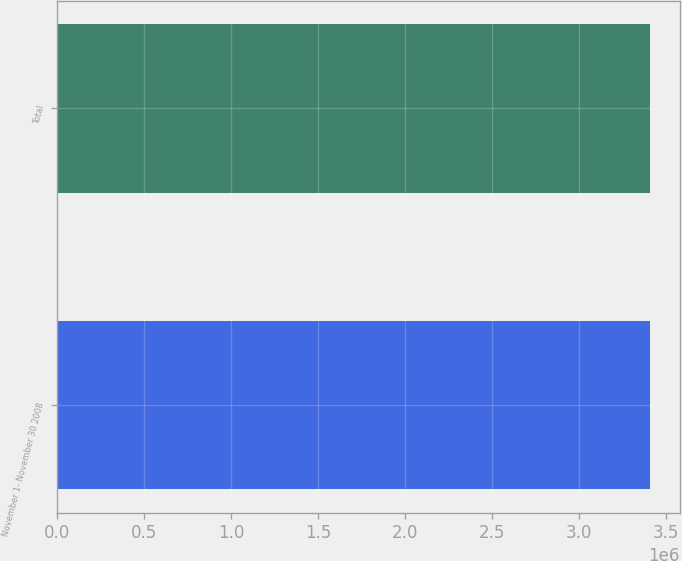Convert chart. <chart><loc_0><loc_0><loc_500><loc_500><bar_chart><fcel>November 1- November 30 2008<fcel>Total<nl><fcel>3.41024e+06<fcel>3.41024e+06<nl></chart> 